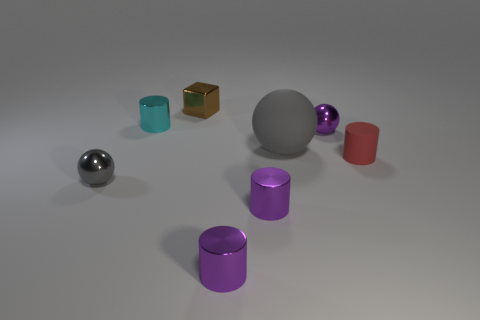There is a tiny cyan object that is behind the gray matte thing; what is its shape?
Your answer should be very brief. Cylinder. What is the size of the gray ball that is made of the same material as the purple ball?
Your response must be concise. Small. The object that is both right of the large sphere and behind the gray matte sphere has what shape?
Make the answer very short. Sphere. There is a small ball that is on the right side of the small gray metal ball; is it the same color as the big object?
Ensure brevity in your answer.  No. There is a rubber object that is behind the tiny red object; is it the same shape as the small cyan shiny thing that is behind the gray shiny ball?
Keep it short and to the point. No. There is a metallic sphere to the left of the small shiny cube; how big is it?
Give a very brief answer. Small. There is a cylinder behind the gray ball behind the small gray metal thing; how big is it?
Offer a very short reply. Small. Is the number of small purple rubber cylinders greater than the number of red rubber things?
Your answer should be very brief. No. Is the number of cyan metallic objects in front of the gray shiny sphere greater than the number of tiny gray metal objects that are behind the big gray thing?
Keep it short and to the point. No. There is a object that is both behind the matte sphere and to the right of the tiny block; what size is it?
Your answer should be very brief. Small. 